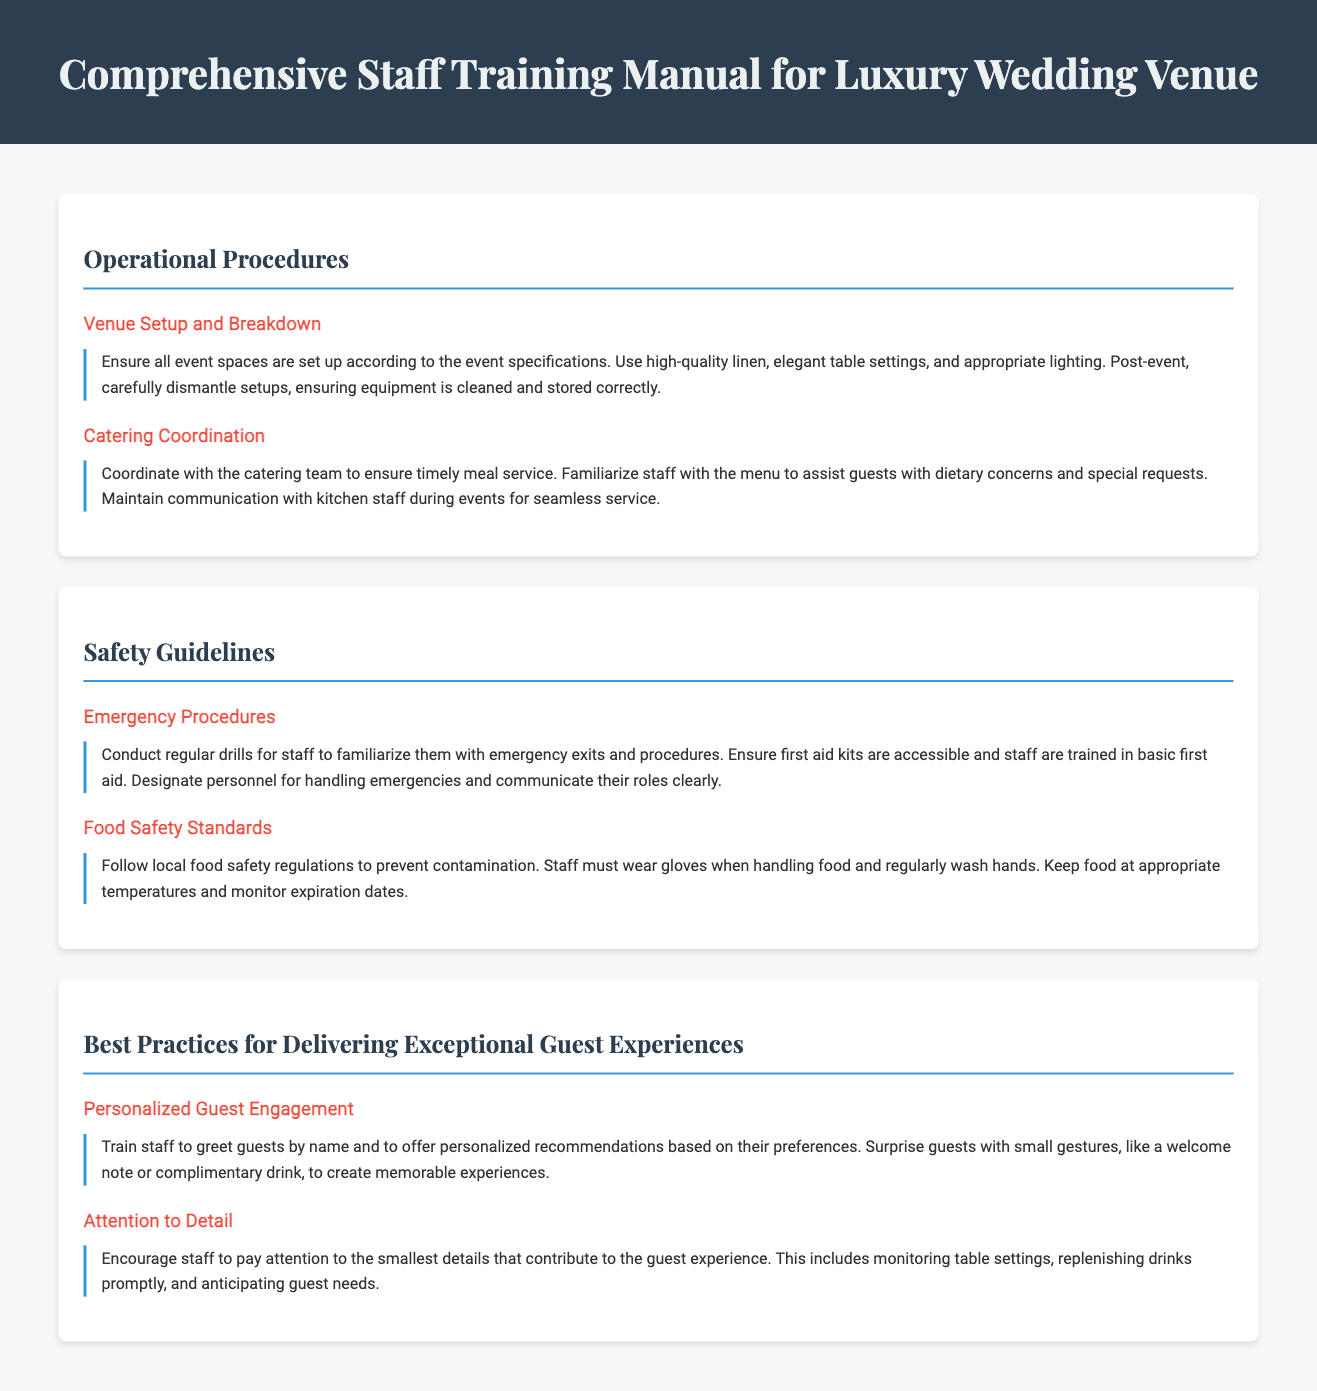what is the title of the document? The title of the document is prominently displayed at the top of the rendered document.
Answer: Comprehensive Staff Training Manual for Luxury Wedding Venue how many sections are in the document? The document is divided into three main sections, each focusing on different areas relevant to the training manual.
Answer: 3 what is one of the best practices for guest experiences mentioned? The document lists specific practices for enhancing guest experiences. This question relates to the content under best practices.
Answer: Personalized Guest Engagement who should be designated for handling emergencies? The document specifies the need for certain personnel to manage emergencies effectively.
Answer: Personnel what are staff required to wear when handling food? Safety guidelines in the document outline specific requirements for food handling to ensure hygiene.
Answer: Gloves what should staff do if a guest has dietary concerns? The document advises staff on how to assist guests regarding dietary issues during meal service.
Answer: Familiarize with the menu what is required during venue setup? The operational procedures detail what should be done during event preparations.
Answer: High-quality linen what is one procedure mentioned for ensuring food safety? The document emphasizes specific protocols that must be followed to maintain food safety standards.
Answer: Wear gloves 